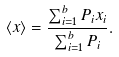<formula> <loc_0><loc_0><loc_500><loc_500>\langle x \rangle = \frac { \sum _ { i = 1 } ^ { b } P _ { i } x _ { i } } { \sum _ { i = 1 } ^ { b } P _ { i } } .</formula> 